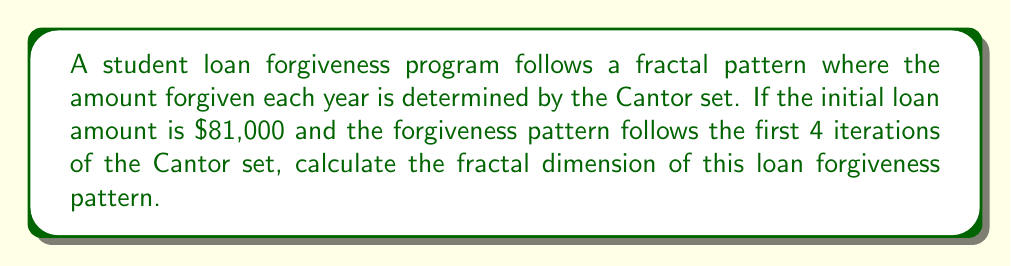What is the answer to this math problem? To solve this problem, we'll follow these steps:

1) Recall that the Cantor set is created by repeatedly removing the middle third of each line segment.

2) The fractal dimension of the Cantor set can be calculated using the box-counting method:

   $$D = \frac{\log N}{\log (1/r)}$$

   Where:
   $N$ = number of self-similar pieces
   $r$ = scaling factor

3) For the Cantor set:
   $N = 2$ (each iteration creates 2 new segments)
   $r = 1/3$ (each new segment is 1/3 the size of the previous)

4) Plugging these values into our equation:

   $$D = \frac{\log 2}{\log 3} \approx 0.6309$$

5) This fractal dimension applies to the loan forgiveness pattern as it follows the Cantor set structure.

6) To visualize this for the given loan:

   Iteration 0: $81,000
   Iteration 1: $27,000 --- $27,000
   Iteration 2: $9,000 --- $9,000 --- $9,000 --- $9,000
   Iteration 3: $3,000 --- $3,000 --- $3,000 --- $3,000 --- $3,000 --- $3,000 --- $3,000 --- $3,000
   Iteration 4: $1,000 (16 segments)

   This pattern continues infinitely in the theoretical Cantor set.
Answer: $\frac{\log 2}{\log 3} \approx 0.6309$ 